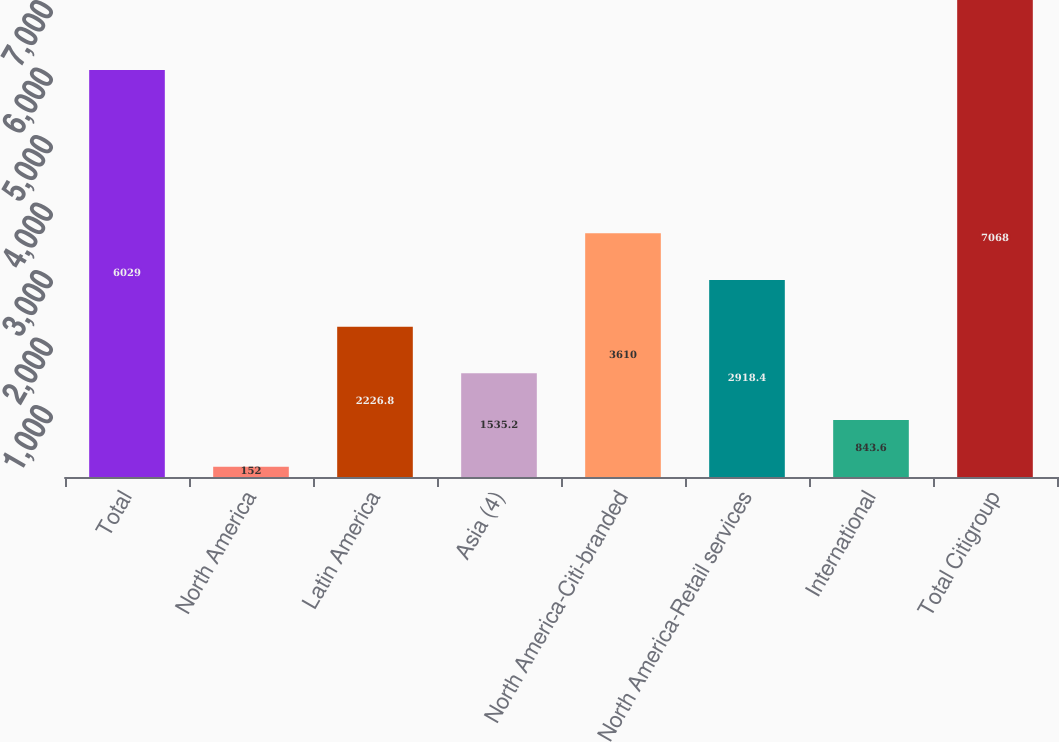<chart> <loc_0><loc_0><loc_500><loc_500><bar_chart><fcel>Total<fcel>North America<fcel>Latin America<fcel>Asia (4)<fcel>North America-Citi-branded<fcel>North America-Retail services<fcel>International<fcel>Total Citigroup<nl><fcel>6029<fcel>152<fcel>2226.8<fcel>1535.2<fcel>3610<fcel>2918.4<fcel>843.6<fcel>7068<nl></chart> 